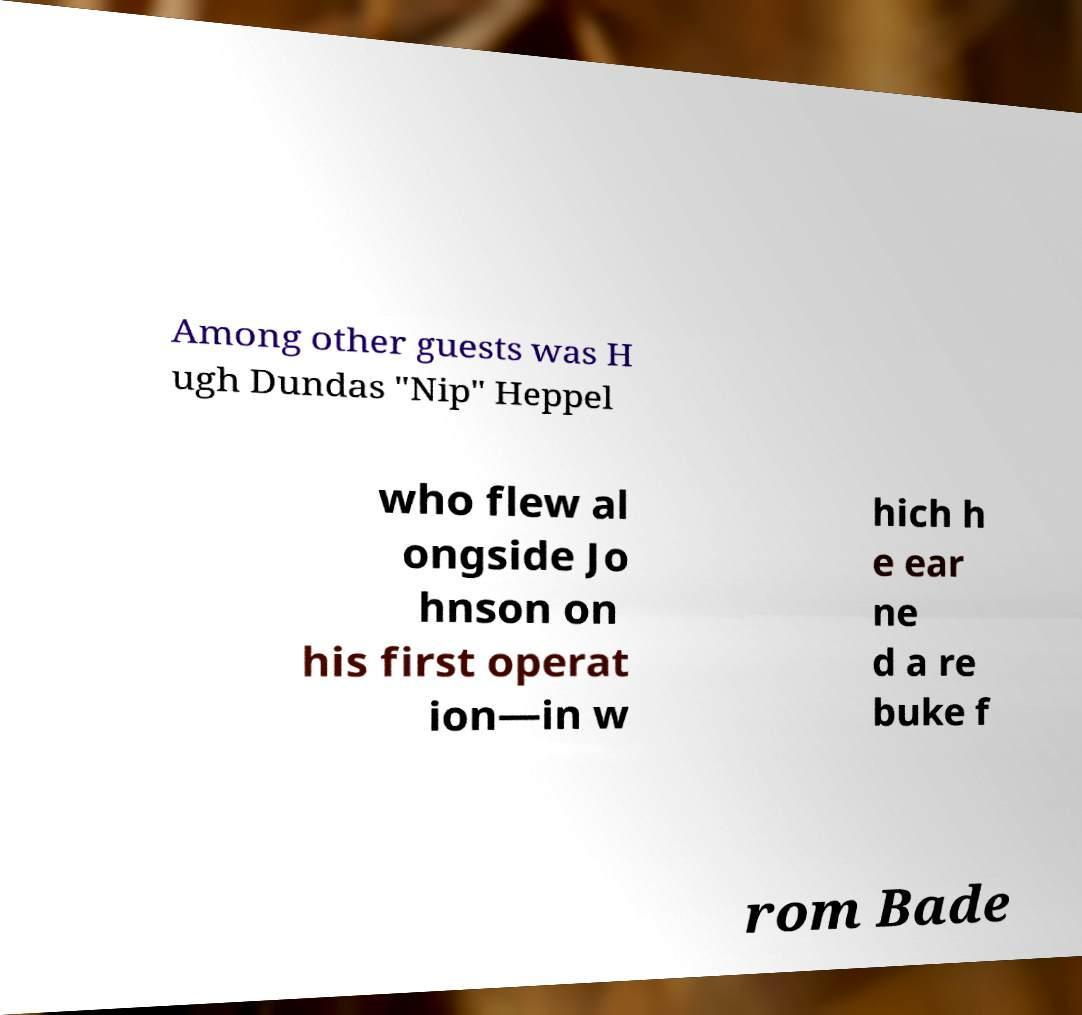For documentation purposes, I need the text within this image transcribed. Could you provide that? Among other guests was H ugh Dundas "Nip" Heppel who flew al ongside Jo hnson on his first operat ion—in w hich h e ear ne d a re buke f rom Bade 